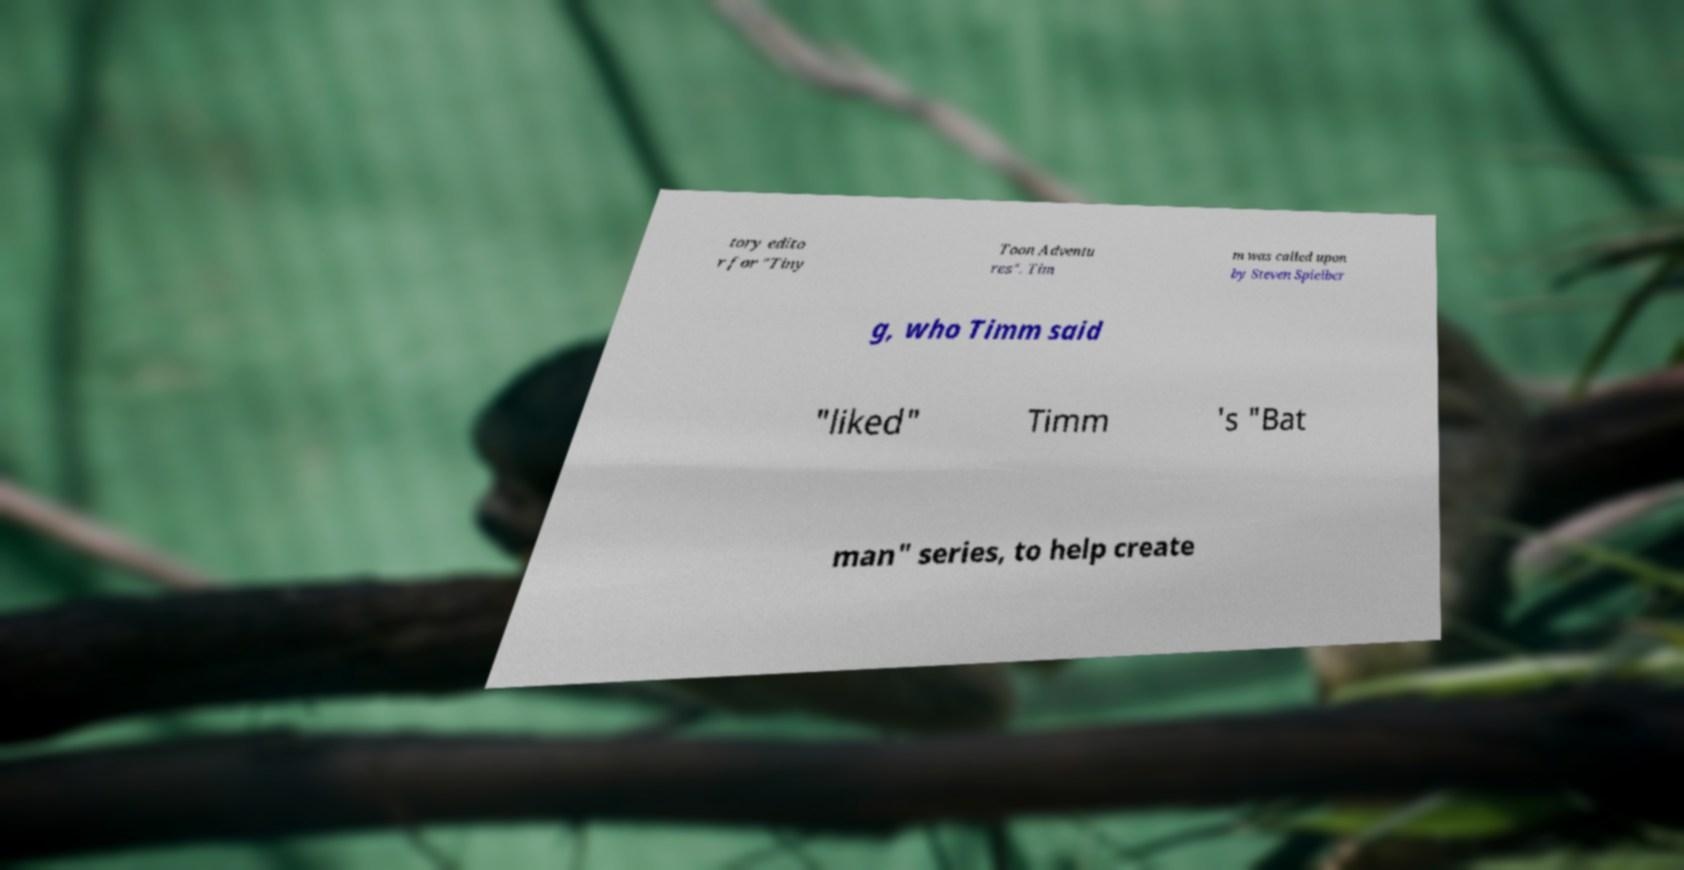What messages or text are displayed in this image? I need them in a readable, typed format. tory edito r for "Tiny Toon Adventu res". Tim m was called upon by Steven Spielber g, who Timm said "liked" Timm 's "Bat man" series, to help create 